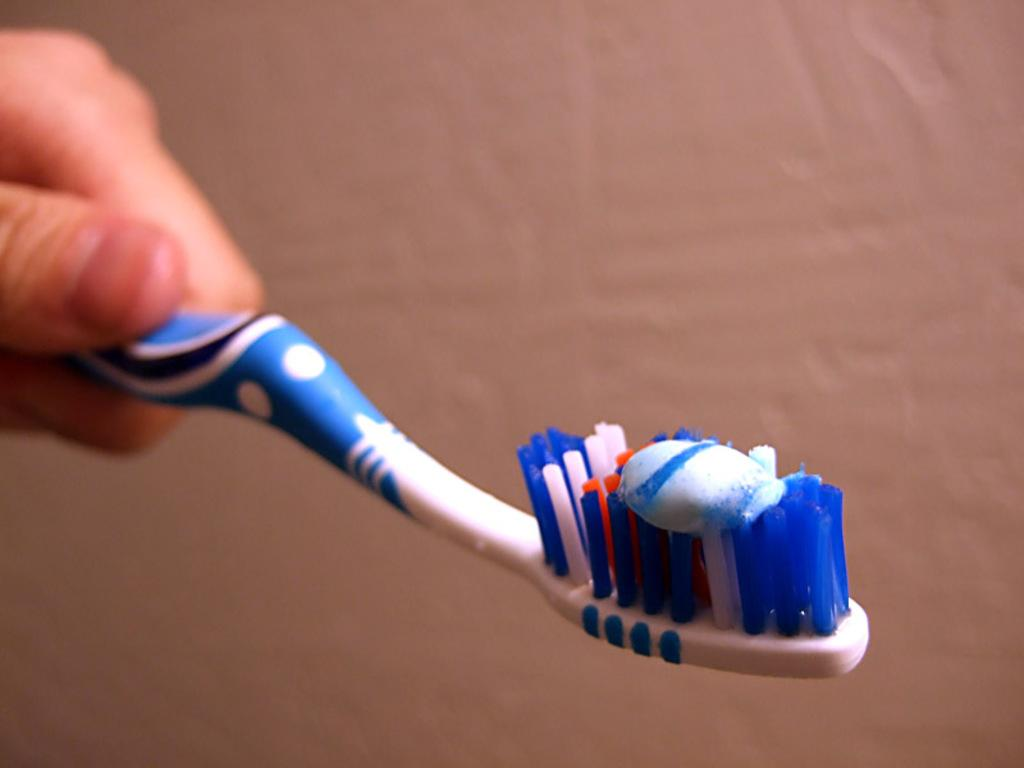What is the hand in the image holding? The hand is holding a brush. What is on the brush that the hand is holding? There is toothpaste on the brush. Where is the faucet located in the image? There is no faucet present in the image. What holiday is being celebrated in the image? There is no indication of a holiday being celebrated in the image. 